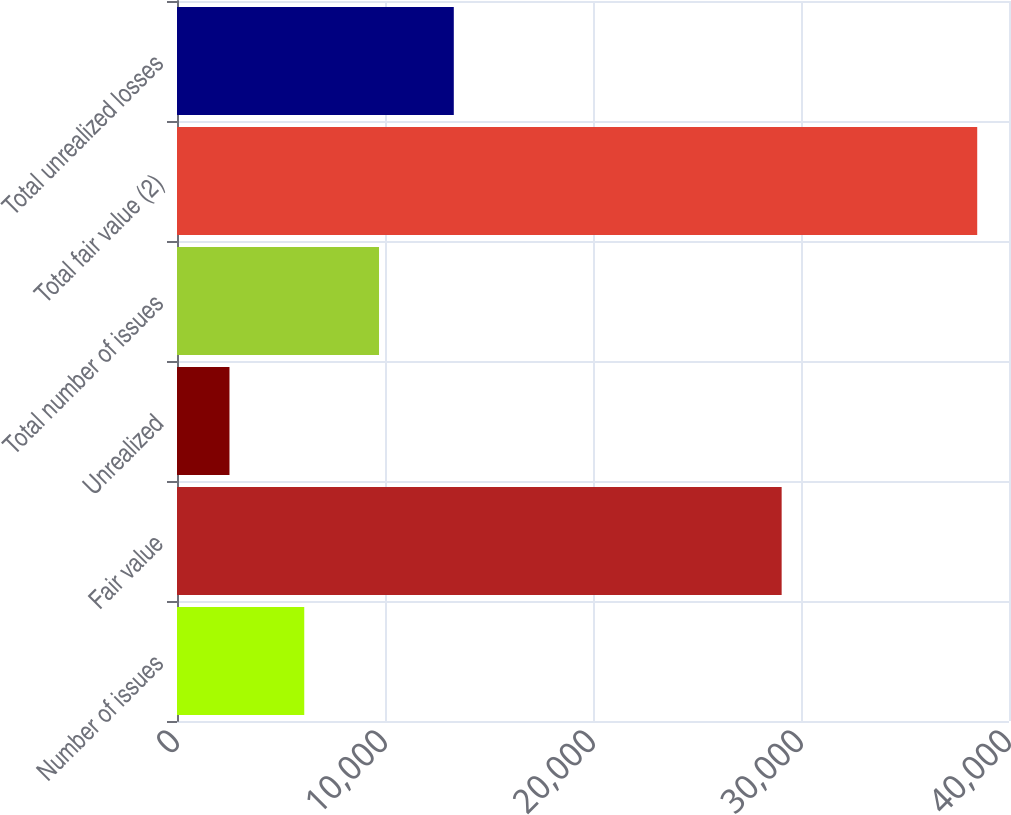<chart> <loc_0><loc_0><loc_500><loc_500><bar_chart><fcel>Number of issues<fcel>Fair value<fcel>Unrealized<fcel>Total number of issues<fcel>Total fair value (2)<fcel>Total unrealized losses<nl><fcel>6117.9<fcel>29070<fcel>2523<fcel>9712.8<fcel>38472<fcel>13307.7<nl></chart> 